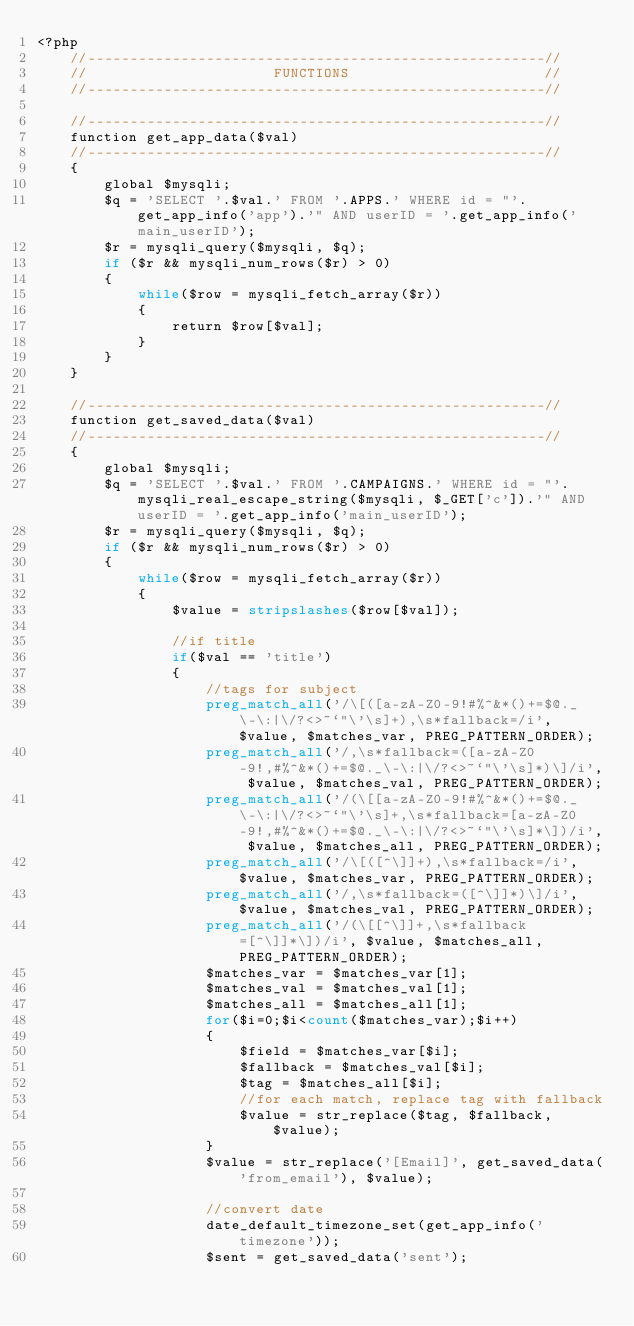Convert code to text. <code><loc_0><loc_0><loc_500><loc_500><_PHP_><?php 
	//------------------------------------------------------//
	//                      FUNCTIONS                       //
	//------------------------------------------------------//
	
	//------------------------------------------------------//
	function get_app_data($val)
	//------------------------------------------------------//
	{
		global $mysqli;		
		$q = 'SELECT '.$val.' FROM '.APPS.' WHERE id = "'.get_app_info('app').'" AND userID = '.get_app_info('main_userID');
		$r = mysqli_query($mysqli, $q);
		if ($r && mysqli_num_rows($r) > 0)
		{
		    while($row = mysqli_fetch_array($r))
		    {
				return $row[$val];
		    }  
		}
	}
	
	//------------------------------------------------------//
	function get_saved_data($val)
	//------------------------------------------------------//
	{
		global $mysqli;
		$q = 'SELECT '.$val.' FROM '.CAMPAIGNS.' WHERE id = "'.mysqli_real_escape_string($mysqli, $_GET['c']).'" AND userID = '.get_app_info('main_userID');
		$r = mysqli_query($mysqli, $q);
		if ($r && mysqli_num_rows($r) > 0)
		{
		    while($row = mysqli_fetch_array($r))
		    {
				$value = stripslashes($row[$val]);
		    	
		    	//if title
		    	if($val == 'title')
		    	{
			    	//tags for subject
					preg_match_all('/\[([a-zA-Z0-9!#%^&*()+=$@._\-\:|\/?<>~`"\'\s]+),\s*fallback=/i', $value, $matches_var, PREG_PATTERN_ORDER);
					preg_match_all('/,\s*fallback=([a-zA-Z0-9!,#%^&*()+=$@._\-\:|\/?<>~`"\'\s]*)\]/i', $value, $matches_val, PREG_PATTERN_ORDER);
					preg_match_all('/(\[[a-zA-Z0-9!#%^&*()+=$@._\-\:|\/?<>~`"\'\s]+,\s*fallback=[a-zA-Z0-9!,#%^&*()+=$@._\-\:|\/?<>~`"\'\s]*\])/i', $value, $matches_all, PREG_PATTERN_ORDER);
					preg_match_all('/\[([^\]]+),\s*fallback=/i', $value, $matches_var, PREG_PATTERN_ORDER);
					preg_match_all('/,\s*fallback=([^\]]*)\]/i', $value, $matches_val, PREG_PATTERN_ORDER);
					preg_match_all('/(\[[^\]]+,\s*fallback=[^\]]*\])/i', $value, $matches_all, PREG_PATTERN_ORDER);
					$matches_var = $matches_var[1];
					$matches_val = $matches_val[1];
					$matches_all = $matches_all[1];
					for($i=0;$i<count($matches_var);$i++)
					{		
						$field = $matches_var[$i];
						$fallback = $matches_val[$i];
						$tag = $matches_all[$i];
						//for each match, replace tag with fallback
						$value = str_replace($tag, $fallback, $value);
					}
					$value = str_replace('[Email]', get_saved_data('from_email'), $value);
					
					//convert date
					date_default_timezone_set(get_app_info('timezone'));
					$sent = get_saved_data('sent');</code> 